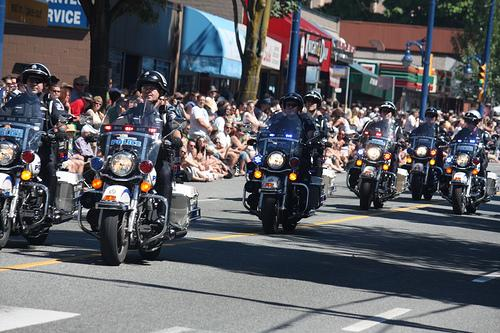Where do you go in this street if you want to buy candy? store 